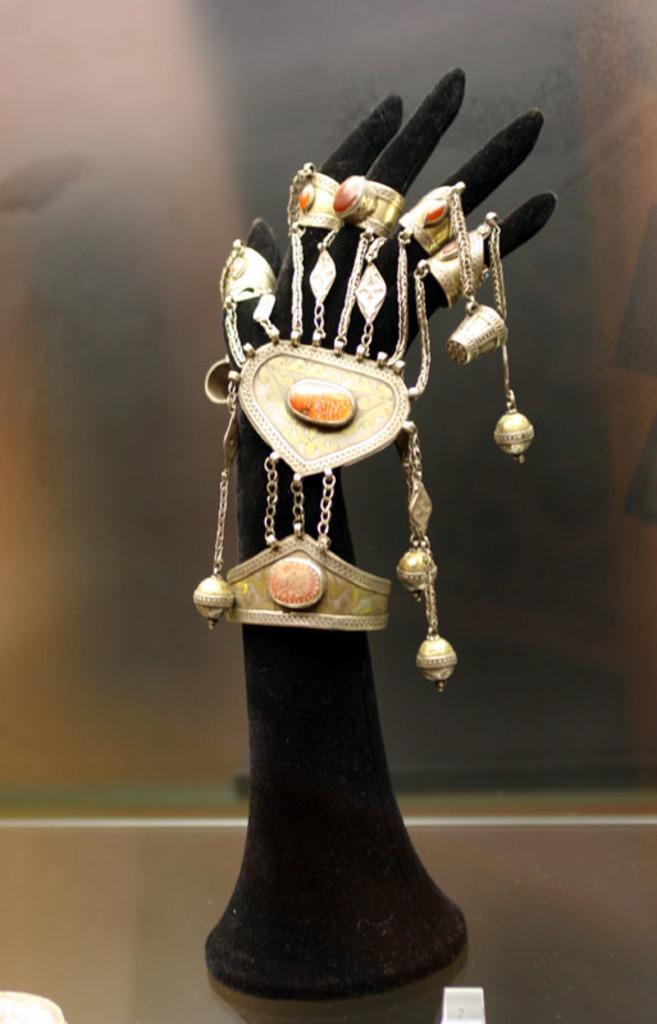Can you describe this image briefly? In this image in the center there are objects which are black and golden in colour. 